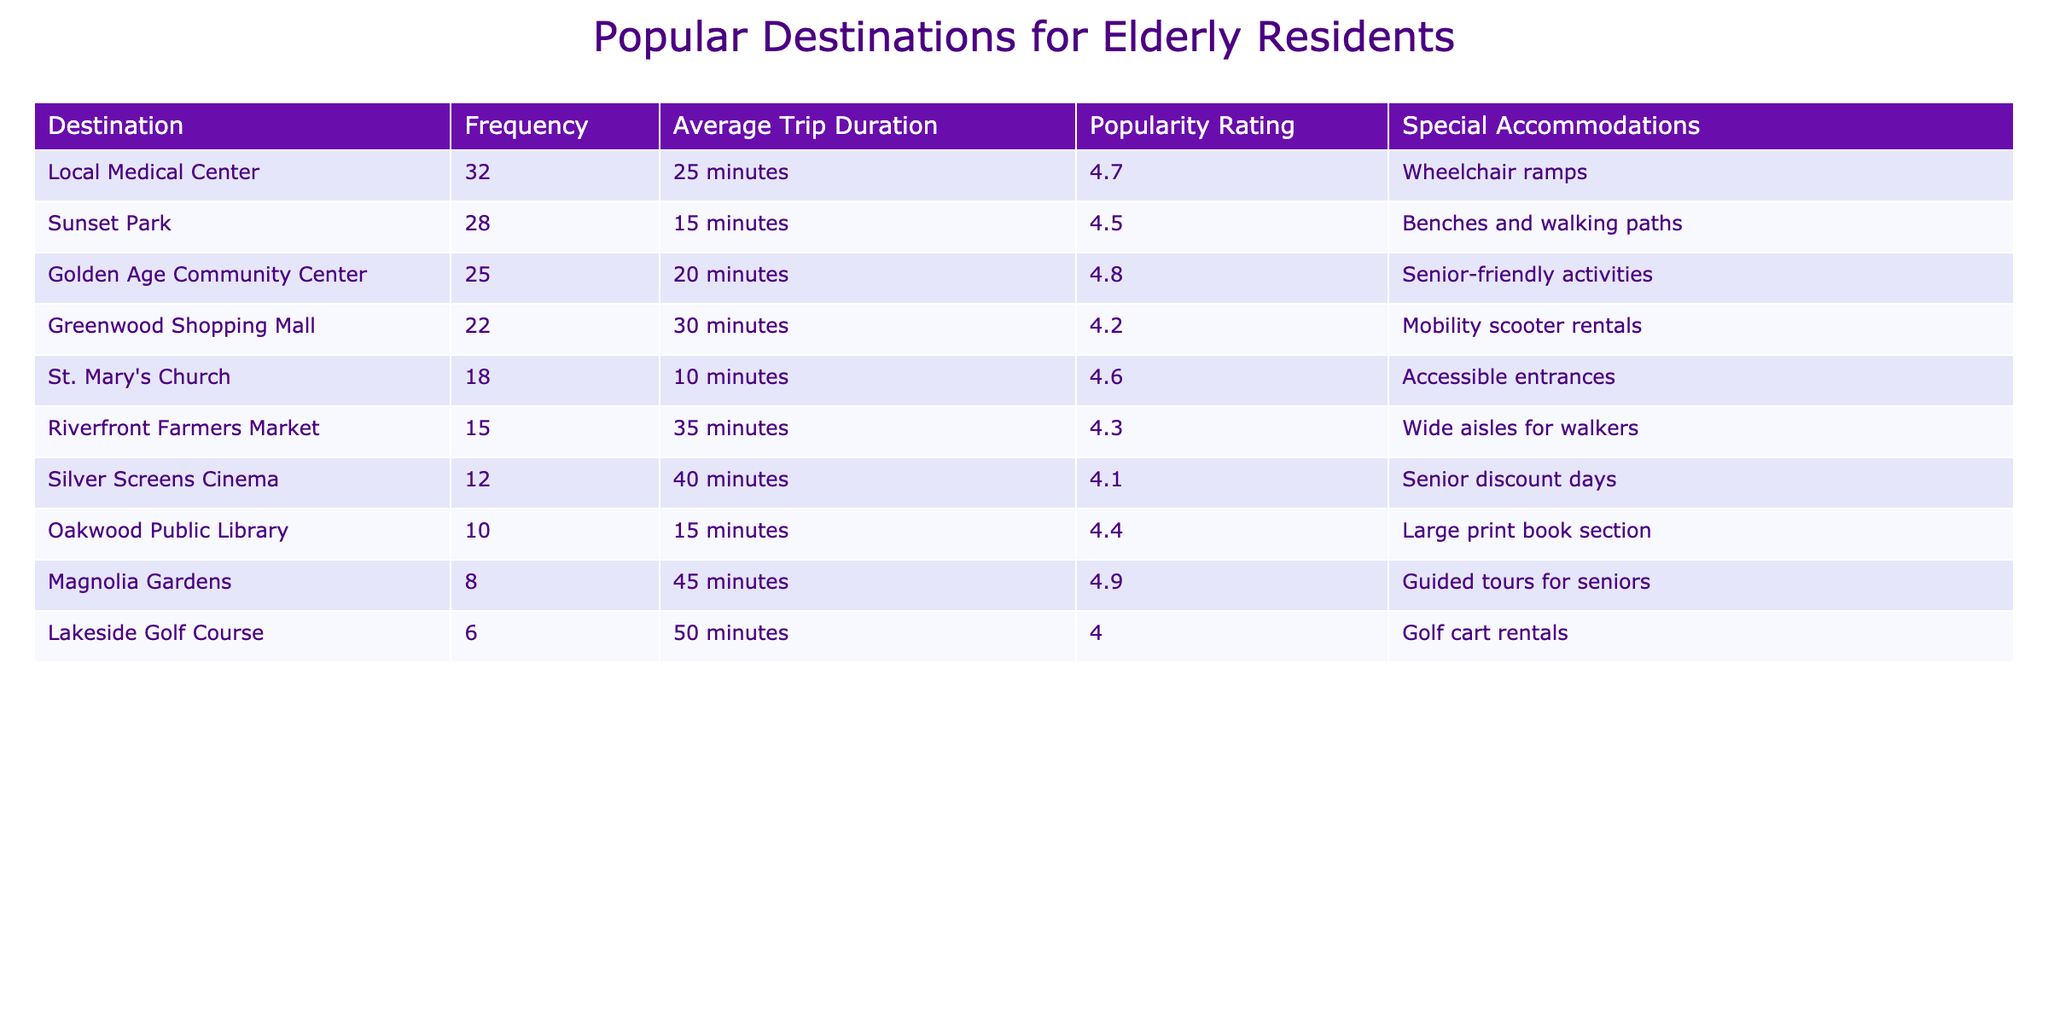What is the most popular destination for elderly residents? The destination with the highest popularity rating in the table is Golden Age Community Center, which has a rating of 4.8.
Answer: Golden Age Community Center How long, on average, does it take to travel to Sunset Park? The average trip duration to Sunset Park is listed as 15 minutes.
Answer: 15 minutes Which destination has the highest frequency of visits? Local Medical Center has the highest frequency of visits at 32.
Answer: 32 Do more people visit the Local Medical Center than the Silver Screens Cinema? Local Medical Center has a frequency of 32 visits, while Silver Screens Cinema has only 12, so it is true that more people visit Local Medical Center.
Answer: Yes What is the average trip duration for all the destinations listed? To find the average trip duration, we sum the durations (25 + 15 + 20 + 30 + 10 + 35 + 40 + 15 + 45 + 50 =  340) and divide by the total number of destinations (10). Therefore, 340 / 10 = 34 minutes.
Answer: 34 minutes How many more visits does the Golden Age Community Center receive compared to Oakwood Public Library? The Golden Age Community Center has 25 visits, and Oakwood Public Library has 10 visits. The difference is 25 - 10 = 15 visits.
Answer: 15 visits Which destination has the longest average trip duration, and what is that duration? The longest average trip duration is at Lakeside Golf Course, which is 50 minutes.
Answer: Lakeside Golf Course, 50 minutes Is there a destination that offers guided tours for seniors? Yes, Magnolia Gardens offers guided tours aimed at seniors, as noted in the special accommodations.
Answer: Yes What is the popularity rating for the Riverfront Farmers Market? The Riverfront Farmers Market has a popularity rating of 4.3 according to the table.
Answer: 4.3 If you combine the frequencies of visits for Sunset Park and Oakwood Public Library, what is the total? Sunset Park has 28 visits and Oakwood Public Library has 10 visits. Adding them together gives 28 + 10 = 38 visits.
Answer: 38 visits 